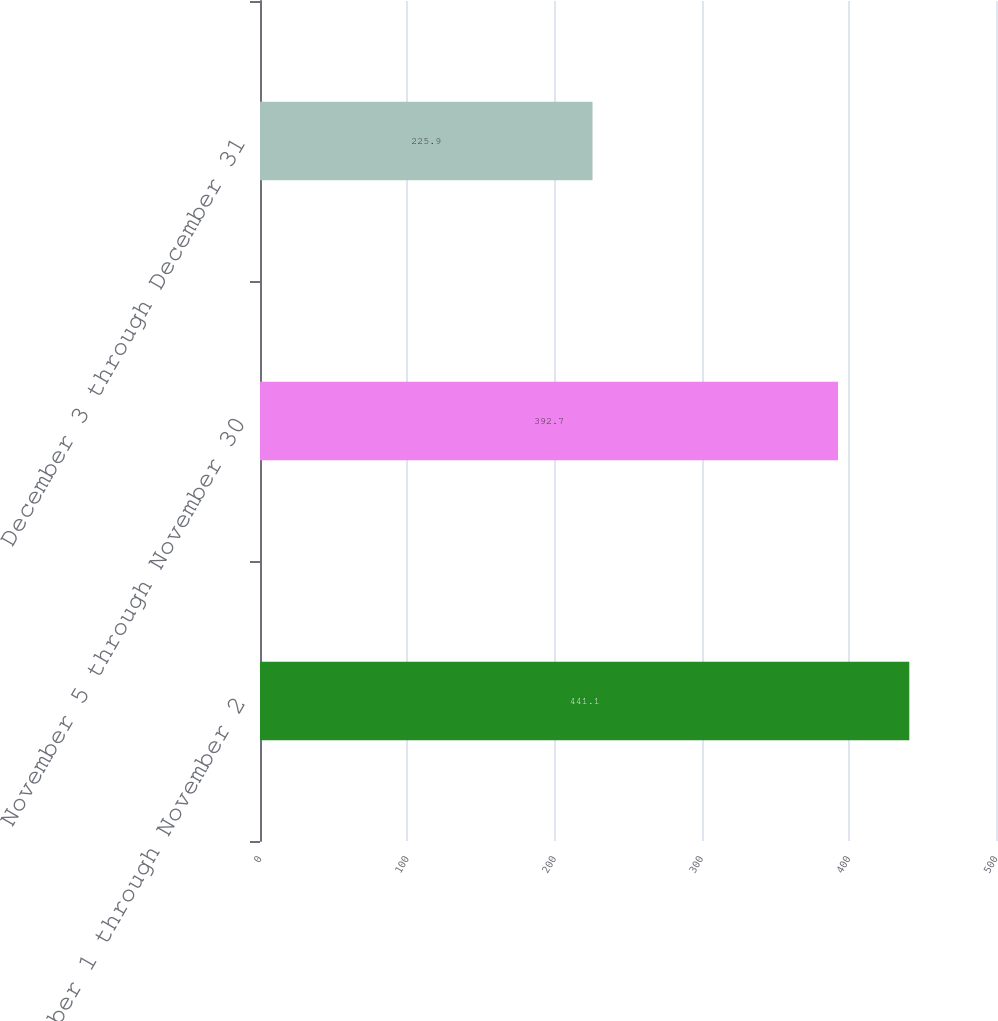<chart> <loc_0><loc_0><loc_500><loc_500><bar_chart><fcel>October 1 through November 2<fcel>November 5 through November 30<fcel>December 3 through December 31<nl><fcel>441.1<fcel>392.7<fcel>225.9<nl></chart> 